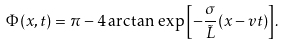<formula> <loc_0><loc_0><loc_500><loc_500>\Phi ( x , t ) = \pi - 4 \arctan { \, \exp { \left [ - \frac { \sigma } { \tilde { L } } ( x - v t ) \right ] } } .</formula> 